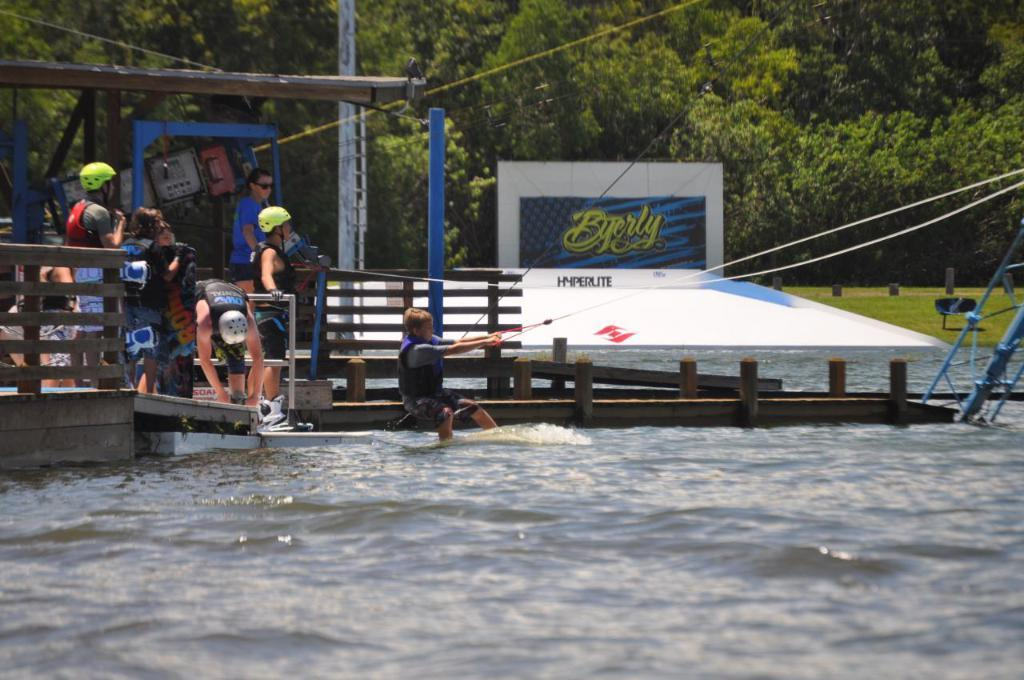<image>
Present a compact description of the photo's key features. Someone is getting ready to wakeboard, with a Byerly advertisement in the background. 